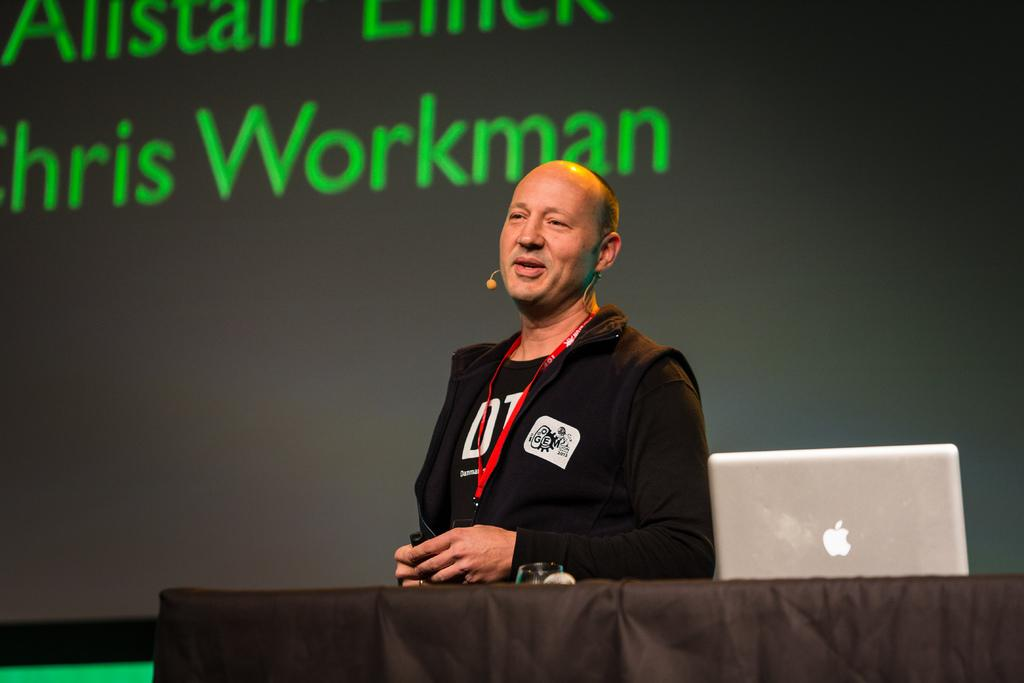<image>
Provide a brief description of the given image. Workman is displayed on the screen behind the man speaking. 